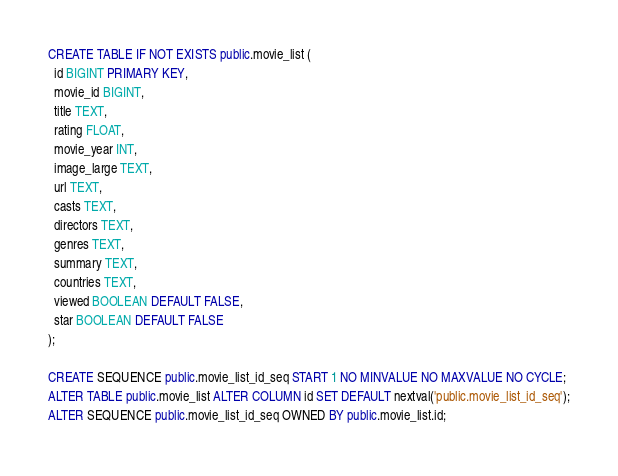<code> <loc_0><loc_0><loc_500><loc_500><_SQL_>CREATE TABLE IF NOT EXISTS public.movie_list (
  id BIGINT PRIMARY KEY,
  movie_id BIGINT,
  title TEXT,
  rating FLOAT,
  movie_year INT,
  image_large TEXT,
  url TEXT,
  casts TEXT,
  directors TEXT,
  genres TEXT,
  summary TEXT,
  countries TEXT,
  viewed BOOLEAN DEFAULT FALSE,
  star BOOLEAN DEFAULT FALSE
);

CREATE SEQUENCE public.movie_list_id_seq START 1 NO MINVALUE NO MAXVALUE NO CYCLE;
ALTER TABLE public.movie_list ALTER COLUMN id SET DEFAULT nextval('public.movie_list_id_seq');
ALTER SEQUENCE public.movie_list_id_seq OWNED BY public.movie_list.id;</code> 